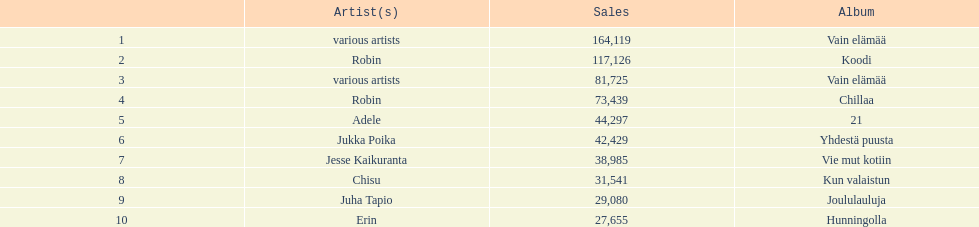Which were the number-one albums of 2012 in finland? Vain elämää, Koodi, Vain elämää, Chillaa, 21, Yhdestä puusta, Vie mut kotiin, Kun valaistun, Joululauluja, Hunningolla. Of those albums, which were by robin? Koodi, Chillaa. Of those albums by robin, which is not chillaa? Koodi. 